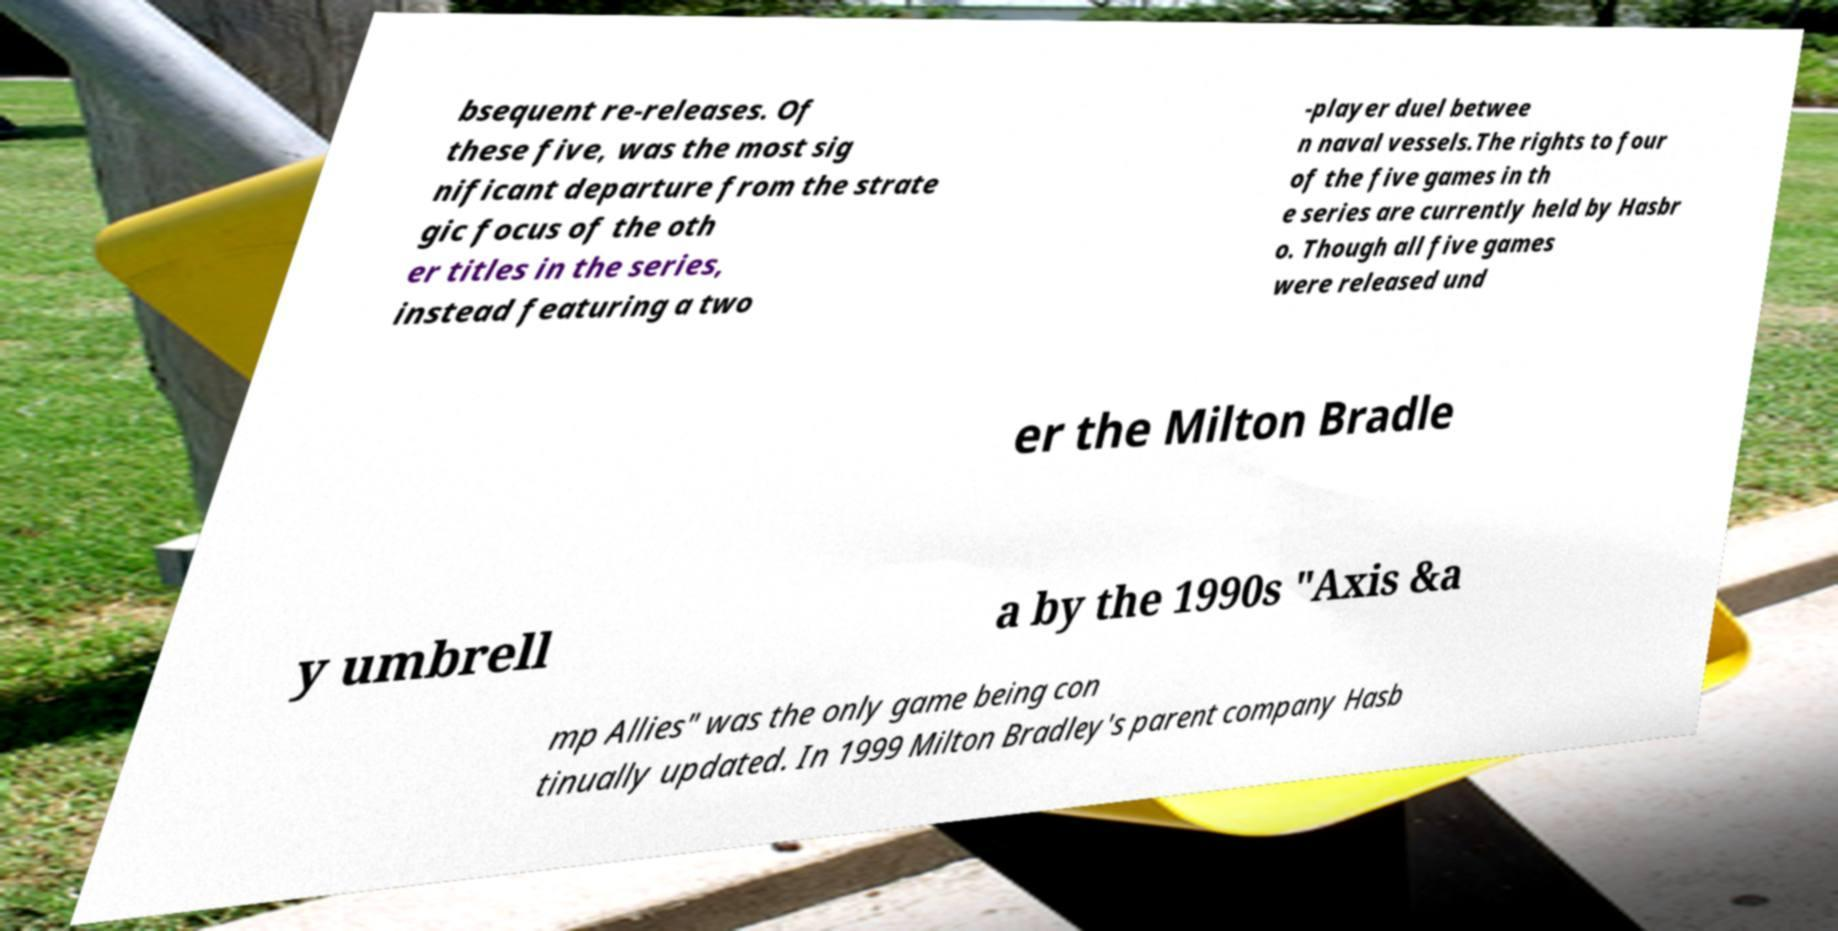I need the written content from this picture converted into text. Can you do that? bsequent re-releases. Of these five, was the most sig nificant departure from the strate gic focus of the oth er titles in the series, instead featuring a two -player duel betwee n naval vessels.The rights to four of the five games in th e series are currently held by Hasbr o. Though all five games were released und er the Milton Bradle y umbrell a by the 1990s "Axis &a mp Allies" was the only game being con tinually updated. In 1999 Milton Bradley's parent company Hasb 